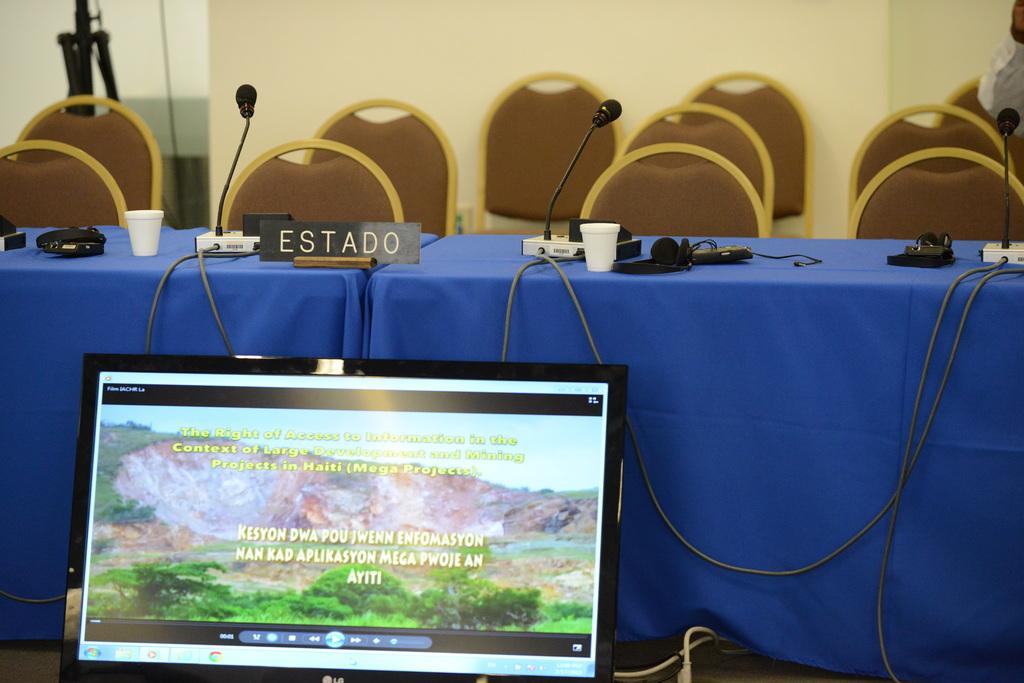What is written on the name plate?
Keep it short and to the point. Estado. 